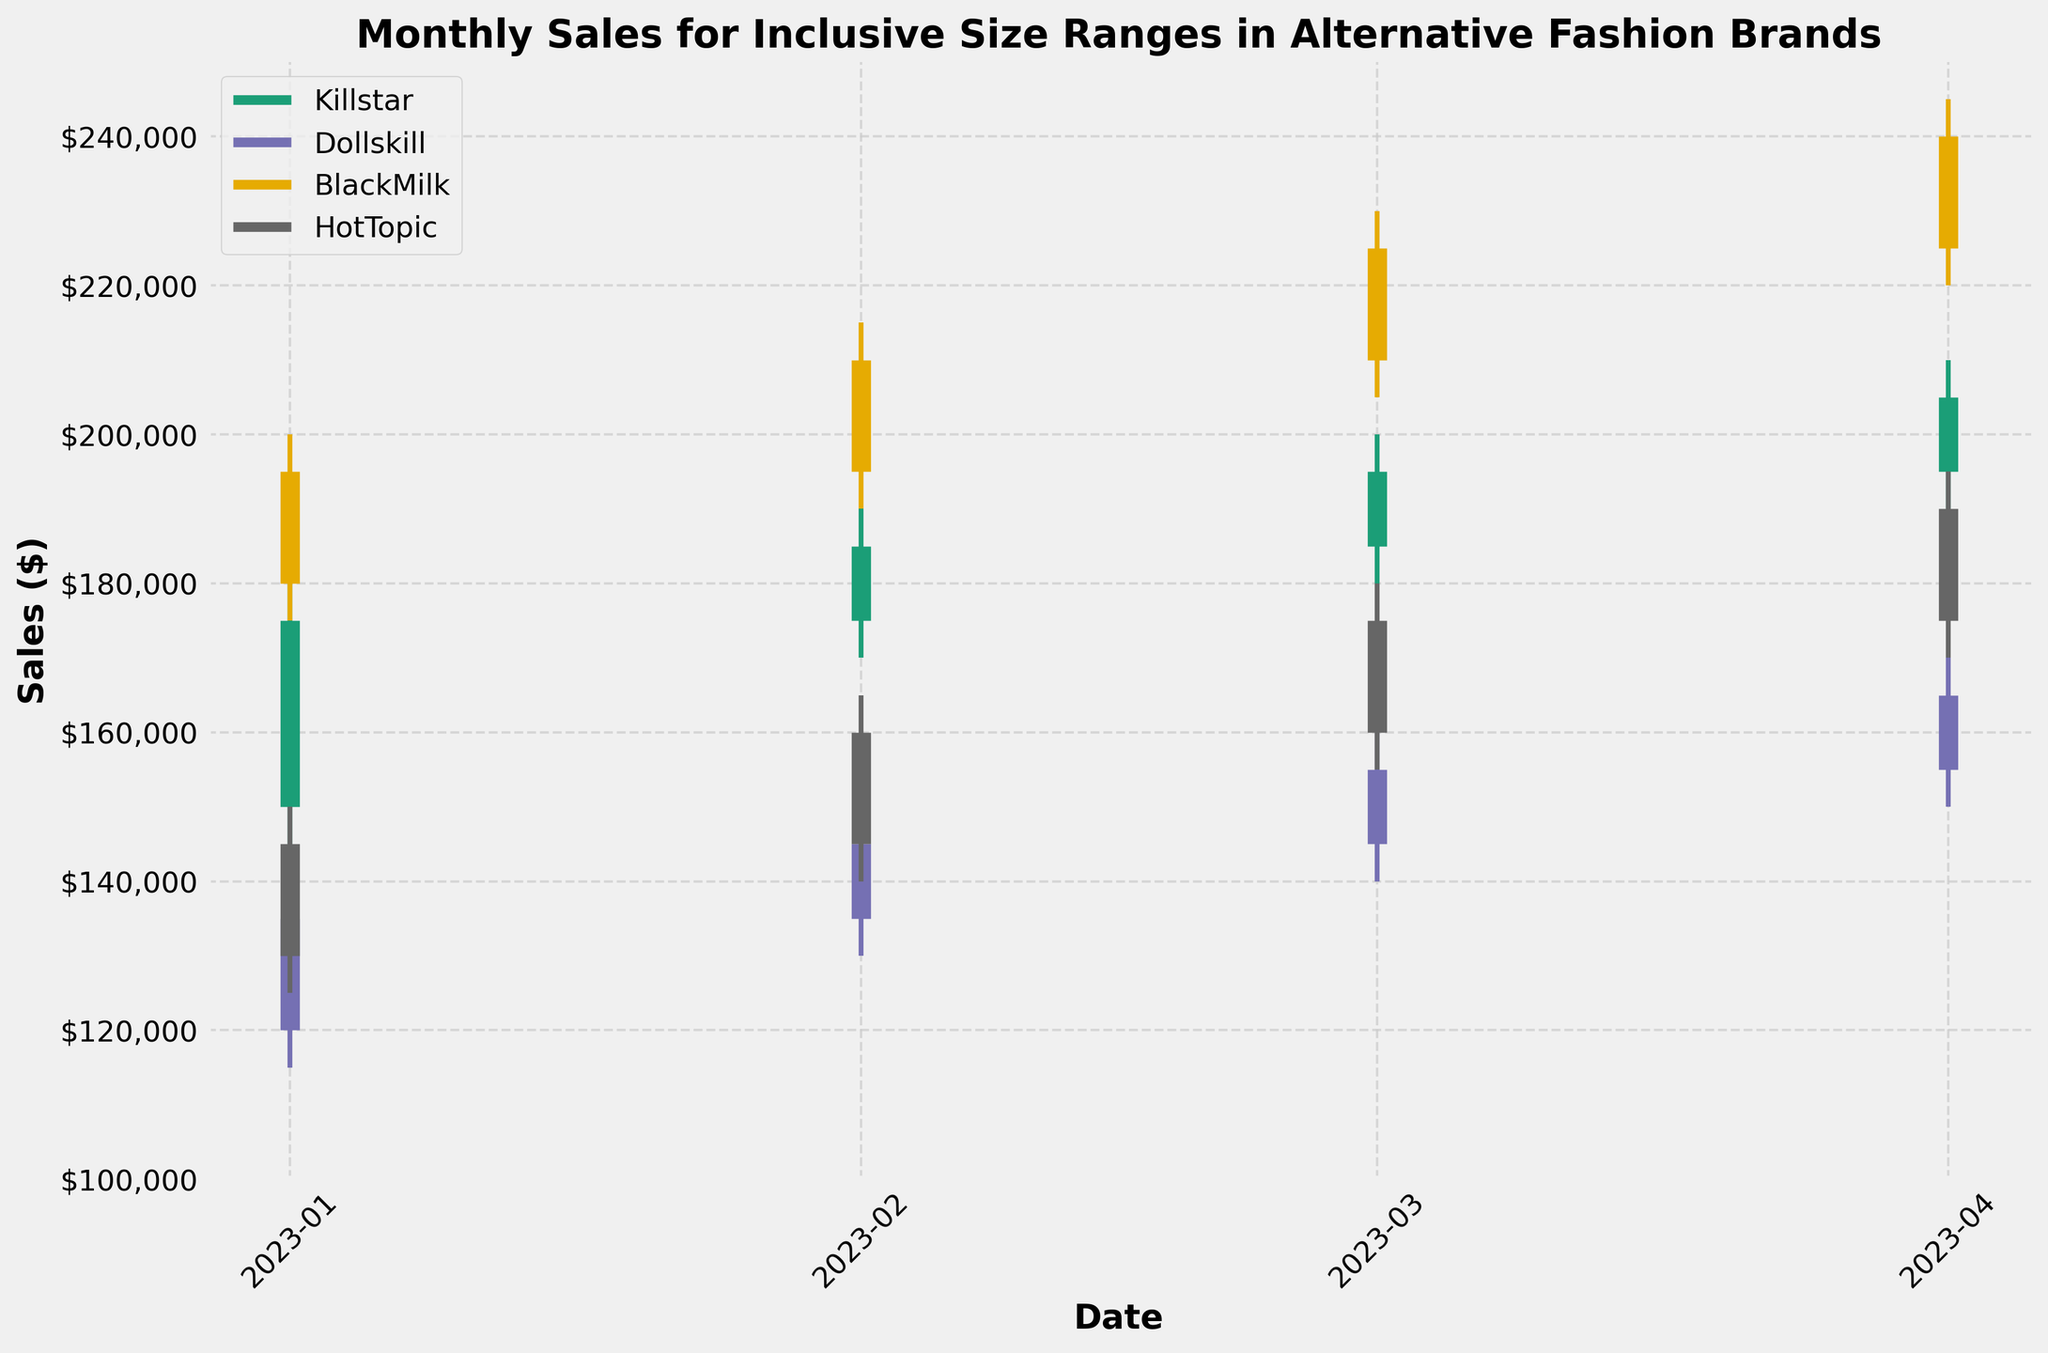What is the title of the figure? The title of the figure is prominently placed at the top of the chart.
Answer: Monthly Sales for Inclusive Size Ranges in Alternative Fashion Brands Which brand has the highest sales figure in April 2023? In April 2023, the tallest bars representing OHLC values show that BlackMilk has the highest sales figures.
Answer: BlackMilk How does the sales performance of Dollskill in January 2023 compare to its performance in February 2023? In January 2023, the closing sales for Dollskill are lower compared to February 2023. Specifically, January closes at $135,000, while February closes at $145,000.
Answer: Higher in February Which month shows the lowest ‘Low’ value for Killstar? By comparing the ‘Low’ values within the Killstar series, January 2023 stands out with the lowest value of $145,000.
Answer: January 2023 What is the range of the highest and lowest sales for BlackMilk in February 2023? In February 2023, BlackMilk's highest sales figure is $215,000, and the lowest is $190,000. Thus, the range is $215,000 - $190,000.
Answer: $25,000 Between January and April 2023, which brand shows the most stable (smallest range between High-Low values) performance? By analyzing the stability (smallest range between High-Low values), HotTopic displays the most stable performance with smaller High-Low fluctuations compared to other brands.
Answer: HotTopic What is the average closing sales for HotTopic from January to April 2023? To find the average, sum the closing sales (145,000 + 160,000 + 175,000 + 190,000) and divide by 4 months. The total is $670,000, and the average is $670,000 / 4.
Answer: $167,500 Which brands consistently showed an increase in their sales from January to April 2023? By visually analyzing the monthly trends, Killstar, Dollskill, BlackMilk, and HotTopic all display consistent increases in their closing sales values from January to April 2023.
Answer: Killstar, Dollskill, BlackMilk, HotTopic Comparing March 2023 and April 2023, which brand experienced the largest increase in its closing sales? The difference between April and March closing values is calculated for each brand. BlackMilk shows the largest increase from $225,000 to $240,000, an increase of $15,000.
Answer: BlackMilk 